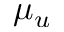Convert formula to latex. <formula><loc_0><loc_0><loc_500><loc_500>\mu _ { u }</formula> 